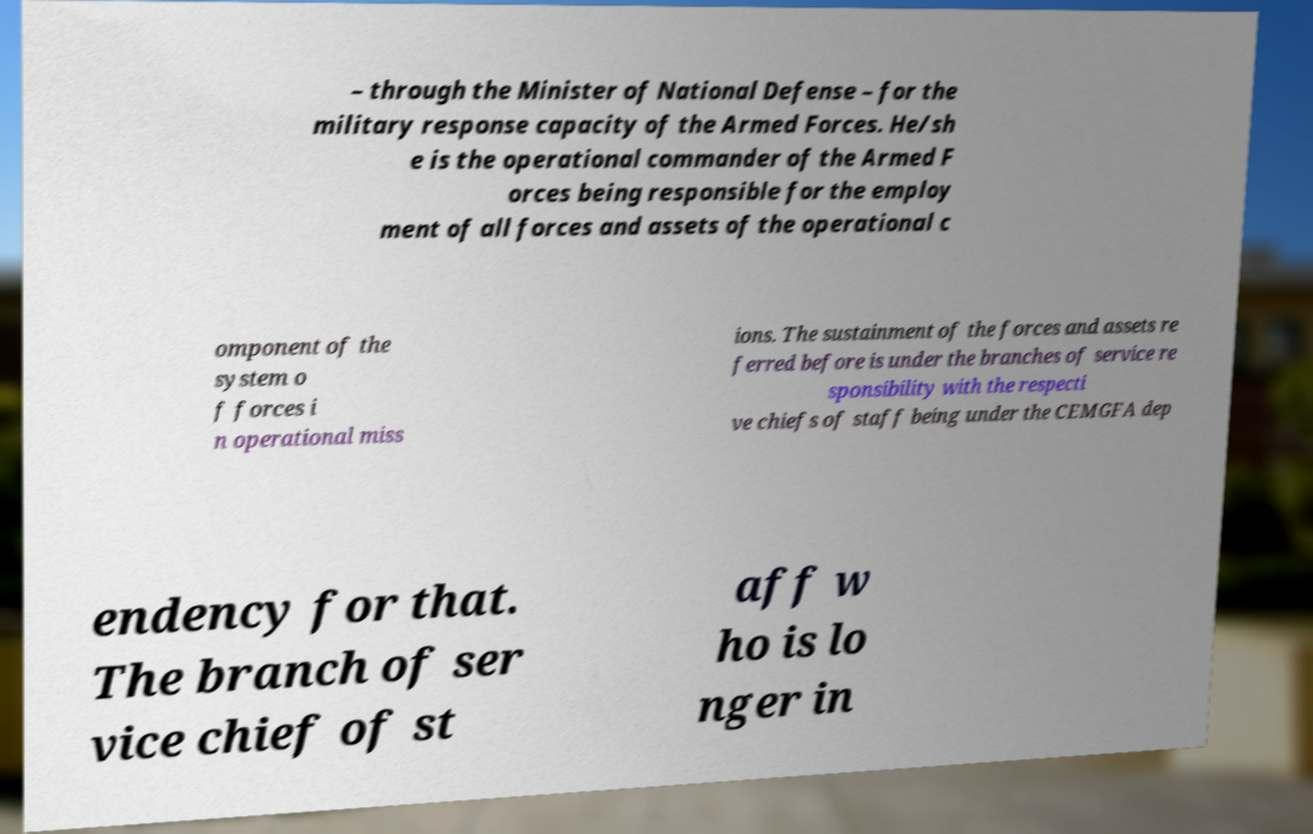Could you assist in decoding the text presented in this image and type it out clearly? – through the Minister of National Defense – for the military response capacity of the Armed Forces. He/sh e is the operational commander of the Armed F orces being responsible for the employ ment of all forces and assets of the operational c omponent of the system o f forces i n operational miss ions. The sustainment of the forces and assets re ferred before is under the branches of service re sponsibility with the respecti ve chiefs of staff being under the CEMGFA dep endency for that. The branch of ser vice chief of st aff w ho is lo nger in 